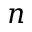Convert formula to latex. <formula><loc_0><loc_0><loc_500><loc_500>n</formula> 